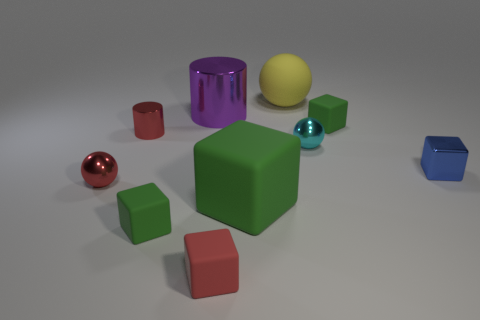How many green blocks must be subtracted to get 1 green blocks? 2 Subtract all yellow balls. How many green cubes are left? 3 Subtract all metal spheres. How many spheres are left? 1 Subtract all blue blocks. How many blocks are left? 4 Subtract all cyan blocks. Subtract all brown cylinders. How many blocks are left? 5 Subtract all cylinders. How many objects are left? 8 Add 6 blue metallic objects. How many blue metallic objects exist? 7 Subtract 1 blue blocks. How many objects are left? 9 Subtract all small blue shiny things. Subtract all tiny blue metal cubes. How many objects are left? 8 Add 3 tiny cyan spheres. How many tiny cyan spheres are left? 4 